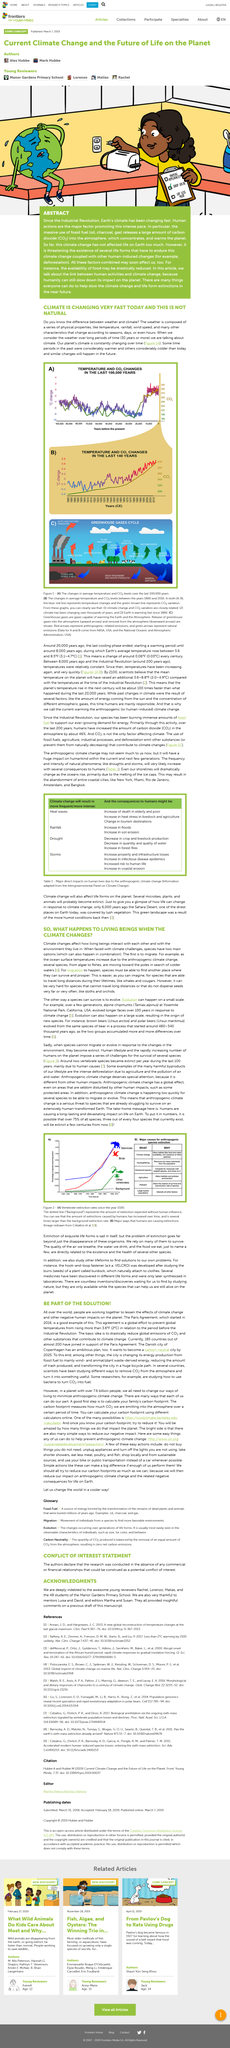Outline some significant characteristics in this image. According to the article, anthropogenic climate change may not seem significant to us now, but it will have a significant impact on the world in the future. In figure A, it is clear that mammals have the highest percentage of extinction, with a majority of their populations having gone extinct. Seventy-five percent of species are at risk of going extinct within a few centuries, according to recent studies. The Paris Agreement started in 2016. The figure depicts the changes in average temperature and CO2 levels from 1880 to 2016. 